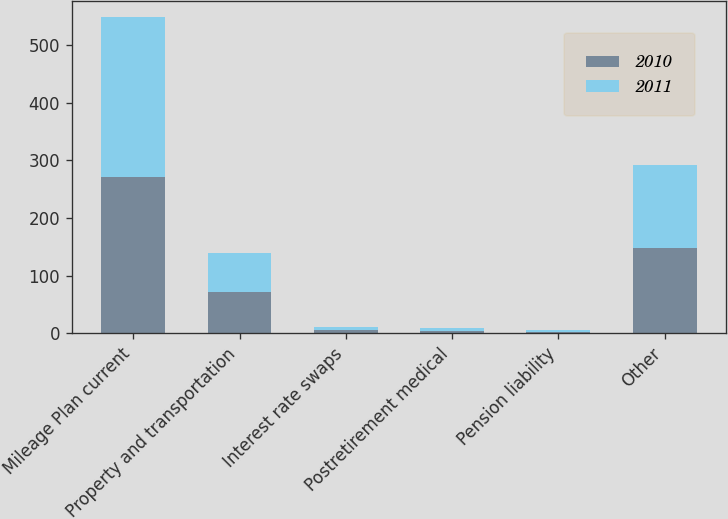Convert chart to OTSL. <chart><loc_0><loc_0><loc_500><loc_500><stacked_bar_chart><ecel><fcel>Mileage Plan current<fcel>Property and transportation<fcel>Interest rate swaps<fcel>Postretirement medical<fcel>Pension liability<fcel>Other<nl><fcel>2010<fcel>271.4<fcel>71.5<fcel>5.2<fcel>4.1<fcel>2.2<fcel>148.6<nl><fcel>2011<fcel>278<fcel>67<fcel>6<fcel>4.9<fcel>2.3<fcel>143<nl></chart> 